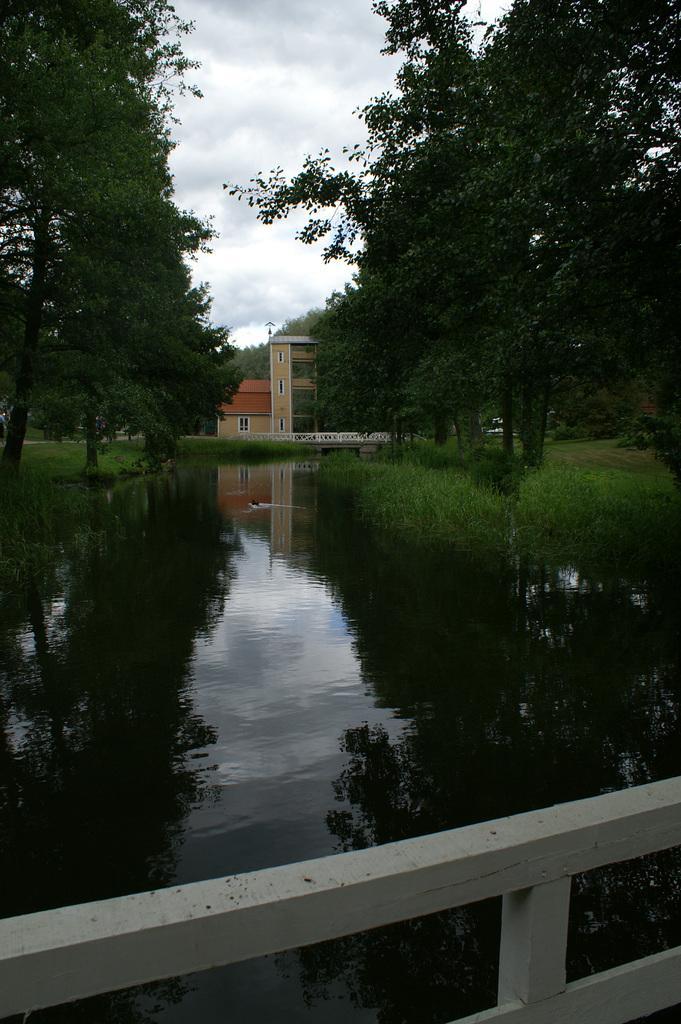Please provide a concise description of this image. In this image there are trees on the left and right corner. There is water at the bottom. There are buildings and trees in the background. And there is sky at the top. 